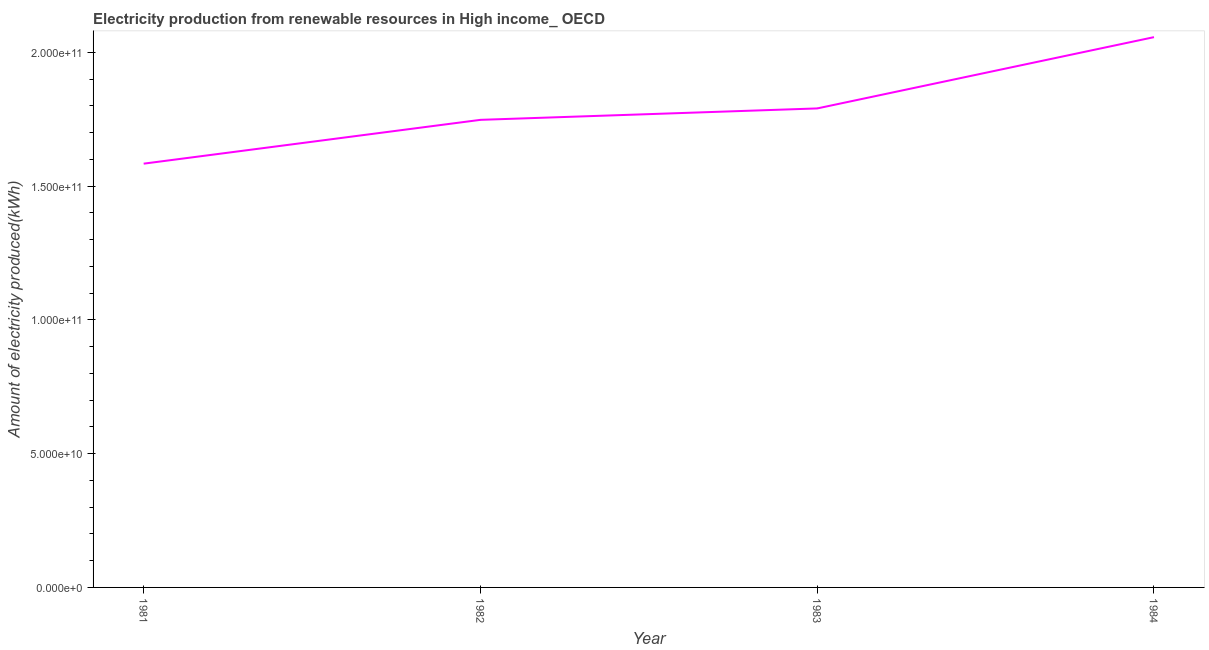What is the amount of electricity produced in 1983?
Offer a terse response. 1.79e+11. Across all years, what is the maximum amount of electricity produced?
Offer a very short reply. 2.06e+11. Across all years, what is the minimum amount of electricity produced?
Your response must be concise. 1.58e+11. In which year was the amount of electricity produced minimum?
Provide a short and direct response. 1981. What is the sum of the amount of electricity produced?
Your answer should be compact. 7.18e+11. What is the difference between the amount of electricity produced in 1981 and 1984?
Ensure brevity in your answer.  -4.73e+1. What is the average amount of electricity produced per year?
Keep it short and to the point. 1.79e+11. What is the median amount of electricity produced?
Your answer should be compact. 1.77e+11. In how many years, is the amount of electricity produced greater than 160000000000 kWh?
Keep it short and to the point. 3. What is the ratio of the amount of electricity produced in 1981 to that in 1984?
Offer a terse response. 0.77. What is the difference between the highest and the second highest amount of electricity produced?
Your response must be concise. 2.66e+1. What is the difference between the highest and the lowest amount of electricity produced?
Ensure brevity in your answer.  4.73e+1. In how many years, is the amount of electricity produced greater than the average amount of electricity produced taken over all years?
Your answer should be compact. 1. Does the amount of electricity produced monotonically increase over the years?
Your answer should be very brief. Yes. How many years are there in the graph?
Provide a short and direct response. 4. Does the graph contain any zero values?
Make the answer very short. No. Does the graph contain grids?
Your response must be concise. No. What is the title of the graph?
Give a very brief answer. Electricity production from renewable resources in High income_ OECD. What is the label or title of the Y-axis?
Your answer should be very brief. Amount of electricity produced(kWh). What is the Amount of electricity produced(kWh) of 1981?
Offer a very short reply. 1.58e+11. What is the Amount of electricity produced(kWh) of 1982?
Your answer should be compact. 1.75e+11. What is the Amount of electricity produced(kWh) in 1983?
Your answer should be compact. 1.79e+11. What is the Amount of electricity produced(kWh) in 1984?
Your answer should be compact. 2.06e+11. What is the difference between the Amount of electricity produced(kWh) in 1981 and 1982?
Offer a very short reply. -1.64e+1. What is the difference between the Amount of electricity produced(kWh) in 1981 and 1983?
Provide a succinct answer. -2.06e+1. What is the difference between the Amount of electricity produced(kWh) in 1981 and 1984?
Provide a succinct answer. -4.73e+1. What is the difference between the Amount of electricity produced(kWh) in 1982 and 1983?
Ensure brevity in your answer.  -4.27e+09. What is the difference between the Amount of electricity produced(kWh) in 1982 and 1984?
Make the answer very short. -3.09e+1. What is the difference between the Amount of electricity produced(kWh) in 1983 and 1984?
Give a very brief answer. -2.66e+1. What is the ratio of the Amount of electricity produced(kWh) in 1981 to that in 1982?
Your response must be concise. 0.91. What is the ratio of the Amount of electricity produced(kWh) in 1981 to that in 1983?
Ensure brevity in your answer.  0.89. What is the ratio of the Amount of electricity produced(kWh) in 1981 to that in 1984?
Provide a short and direct response. 0.77. What is the ratio of the Amount of electricity produced(kWh) in 1982 to that in 1984?
Give a very brief answer. 0.85. What is the ratio of the Amount of electricity produced(kWh) in 1983 to that in 1984?
Provide a succinct answer. 0.87. 